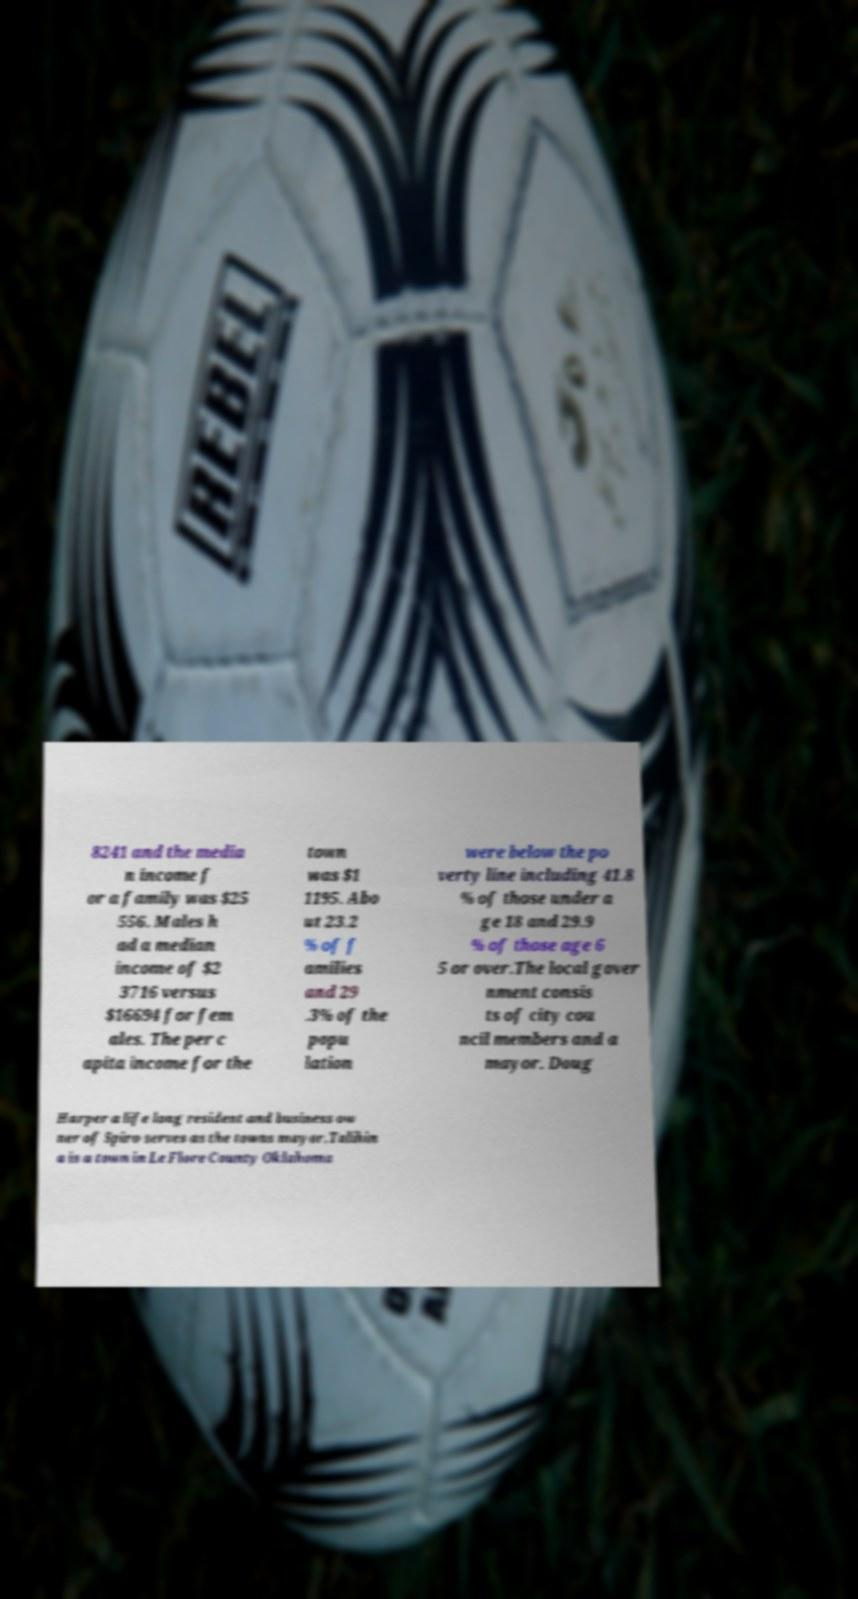I need the written content from this picture converted into text. Can you do that? 8241 and the media n income f or a family was $25 556. Males h ad a median income of $2 3716 versus $16694 for fem ales. The per c apita income for the town was $1 1195. Abo ut 23.2 % of f amilies and 29 .3% of the popu lation were below the po verty line including 41.8 % of those under a ge 18 and 29.9 % of those age 6 5 or over.The local gover nment consis ts of city cou ncil members and a mayor. Doug Harper a life long resident and business ow ner of Spiro serves as the towns mayor.Talihin a is a town in Le Flore County Oklahoma 